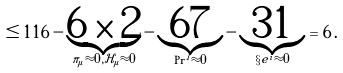<formula> <loc_0><loc_0><loc_500><loc_500>\leq 1 1 6 - \underbrace { 6 \times 2 } _ { \pi _ { \mu } \approx 0 , \mathcal { H } _ { \mu } \approx 0 } - \underbrace { 6 7 } _ { \Pr ^ { I } \approx 0 } - \underbrace { 3 1 } _ { \S e ^ { i } \approx 0 } = 6 \, .</formula> 